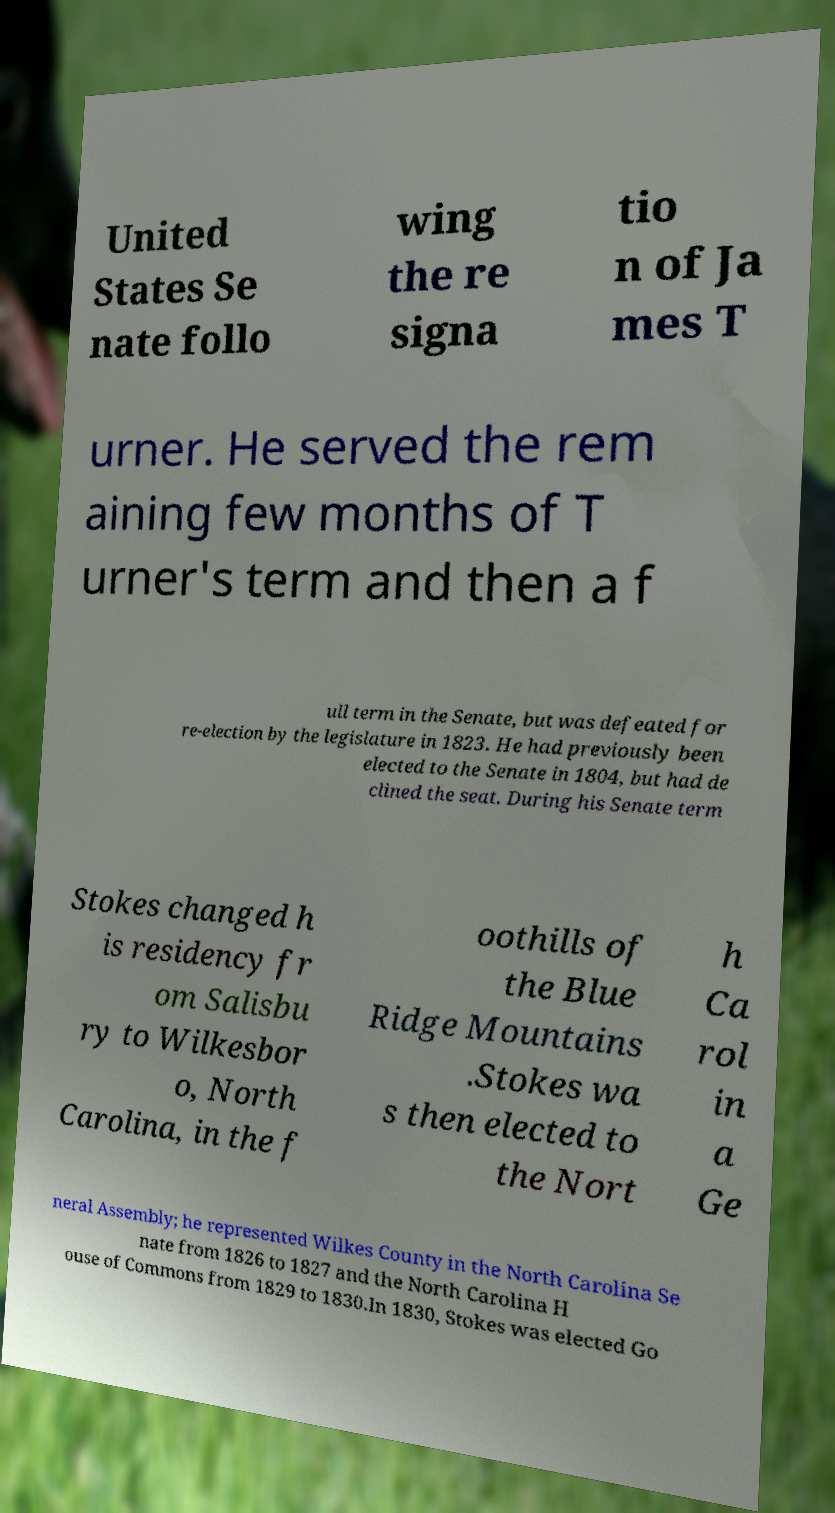There's text embedded in this image that I need extracted. Can you transcribe it verbatim? United States Se nate follo wing the re signa tio n of Ja mes T urner. He served the rem aining few months of T urner's term and then a f ull term in the Senate, but was defeated for re-election by the legislature in 1823. He had previously been elected to the Senate in 1804, but had de clined the seat. During his Senate term Stokes changed h is residency fr om Salisbu ry to Wilkesbor o, North Carolina, in the f oothills of the Blue Ridge Mountains .Stokes wa s then elected to the Nort h Ca rol in a Ge neral Assembly; he represented Wilkes County in the North Carolina Se nate from 1826 to 1827 and the North Carolina H ouse of Commons from 1829 to 1830.In 1830, Stokes was elected Go 